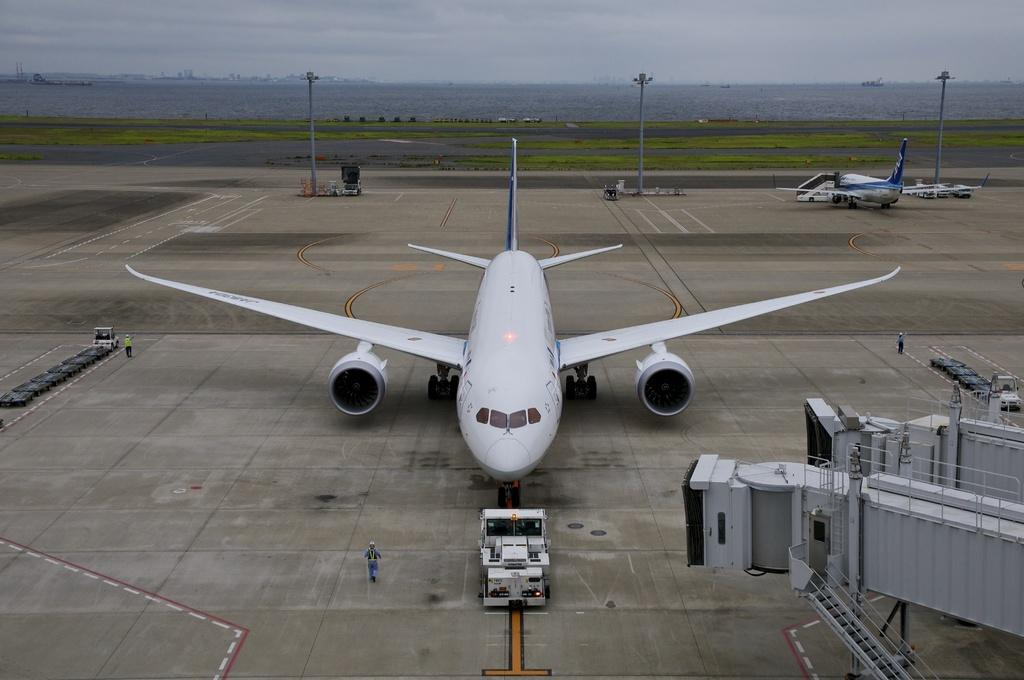What is the main subject of the picture? The main subject of the picture is aeroplanes. What else can be seen in the picture besides aeroplanes? There are men, vehicles, pole lights, buildings, water, and a cloudy sky visible in the picture. What type of lettuce is being used to grip the aeroplanes in the picture? There is no lettuce present in the image, and aeroplanes are not being gripped by any object. 